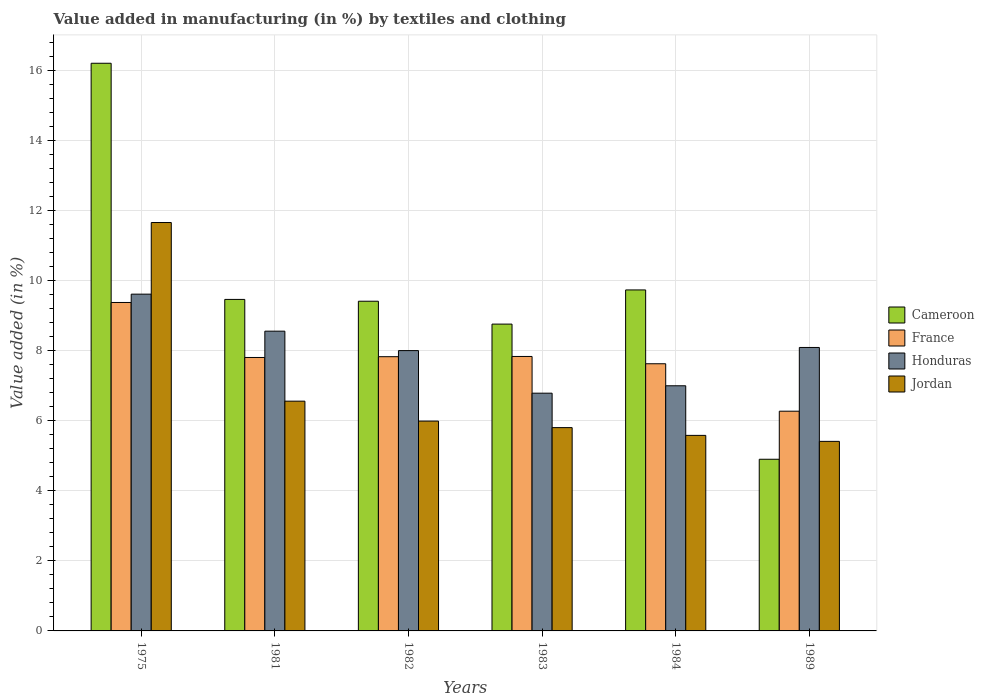How many different coloured bars are there?
Provide a short and direct response. 4. Are the number of bars on each tick of the X-axis equal?
Give a very brief answer. Yes. How many bars are there on the 6th tick from the left?
Your response must be concise. 4. What is the percentage of value added in manufacturing by textiles and clothing in France in 1984?
Your answer should be very brief. 7.63. Across all years, what is the maximum percentage of value added in manufacturing by textiles and clothing in France?
Provide a succinct answer. 9.38. Across all years, what is the minimum percentage of value added in manufacturing by textiles and clothing in Jordan?
Your answer should be compact. 5.41. In which year was the percentage of value added in manufacturing by textiles and clothing in Cameroon maximum?
Give a very brief answer. 1975. What is the total percentage of value added in manufacturing by textiles and clothing in France in the graph?
Provide a short and direct response. 46.77. What is the difference between the percentage of value added in manufacturing by textiles and clothing in Honduras in 1975 and that in 1983?
Keep it short and to the point. 2.83. What is the difference between the percentage of value added in manufacturing by textiles and clothing in Cameroon in 1975 and the percentage of value added in manufacturing by textiles and clothing in France in 1989?
Ensure brevity in your answer.  9.94. What is the average percentage of value added in manufacturing by textiles and clothing in Cameroon per year?
Your response must be concise. 9.75. In the year 1989, what is the difference between the percentage of value added in manufacturing by textiles and clothing in Cameroon and percentage of value added in manufacturing by textiles and clothing in Jordan?
Your response must be concise. -0.51. In how many years, is the percentage of value added in manufacturing by textiles and clothing in Jordan greater than 6.4 %?
Your response must be concise. 2. What is the ratio of the percentage of value added in manufacturing by textiles and clothing in Honduras in 1981 to that in 1989?
Give a very brief answer. 1.06. Is the percentage of value added in manufacturing by textiles and clothing in Honduras in 1981 less than that in 1983?
Your answer should be very brief. No. What is the difference between the highest and the second highest percentage of value added in manufacturing by textiles and clothing in Cameroon?
Make the answer very short. 6.47. What is the difference between the highest and the lowest percentage of value added in manufacturing by textiles and clothing in Jordan?
Offer a terse response. 6.25. In how many years, is the percentage of value added in manufacturing by textiles and clothing in Jordan greater than the average percentage of value added in manufacturing by textiles and clothing in Jordan taken over all years?
Offer a very short reply. 1. What does the 4th bar from the left in 1989 represents?
Your answer should be very brief. Jordan. What does the 4th bar from the right in 1982 represents?
Your answer should be very brief. Cameroon. Is it the case that in every year, the sum of the percentage of value added in manufacturing by textiles and clothing in Jordan and percentage of value added in manufacturing by textiles and clothing in Honduras is greater than the percentage of value added in manufacturing by textiles and clothing in France?
Offer a very short reply. Yes. How many years are there in the graph?
Provide a short and direct response. 6. Are the values on the major ticks of Y-axis written in scientific E-notation?
Your response must be concise. No. Does the graph contain grids?
Your response must be concise. Yes. How are the legend labels stacked?
Provide a short and direct response. Vertical. What is the title of the graph?
Offer a very short reply. Value added in manufacturing (in %) by textiles and clothing. What is the label or title of the X-axis?
Your response must be concise. Years. What is the label or title of the Y-axis?
Provide a succinct answer. Value added (in %). What is the Value added (in %) in Cameroon in 1975?
Your response must be concise. 16.21. What is the Value added (in %) of France in 1975?
Your answer should be compact. 9.38. What is the Value added (in %) of Honduras in 1975?
Keep it short and to the point. 9.62. What is the Value added (in %) of Jordan in 1975?
Make the answer very short. 11.66. What is the Value added (in %) in Cameroon in 1981?
Provide a short and direct response. 9.47. What is the Value added (in %) of France in 1981?
Keep it short and to the point. 7.81. What is the Value added (in %) in Honduras in 1981?
Offer a very short reply. 8.56. What is the Value added (in %) of Jordan in 1981?
Provide a short and direct response. 6.56. What is the Value added (in %) in Cameroon in 1982?
Make the answer very short. 9.42. What is the Value added (in %) in France in 1982?
Offer a terse response. 7.83. What is the Value added (in %) in Honduras in 1982?
Your answer should be very brief. 8.01. What is the Value added (in %) of Jordan in 1982?
Your answer should be compact. 5.99. What is the Value added (in %) of Cameroon in 1983?
Keep it short and to the point. 8.76. What is the Value added (in %) in France in 1983?
Make the answer very short. 7.84. What is the Value added (in %) in Honduras in 1983?
Give a very brief answer. 6.79. What is the Value added (in %) in Jordan in 1983?
Provide a succinct answer. 5.81. What is the Value added (in %) in Cameroon in 1984?
Ensure brevity in your answer.  9.74. What is the Value added (in %) of France in 1984?
Provide a succinct answer. 7.63. What is the Value added (in %) of Honduras in 1984?
Offer a terse response. 7. What is the Value added (in %) of Jordan in 1984?
Ensure brevity in your answer.  5.58. What is the Value added (in %) in Cameroon in 1989?
Provide a succinct answer. 4.9. What is the Value added (in %) in France in 1989?
Keep it short and to the point. 6.28. What is the Value added (in %) of Honduras in 1989?
Keep it short and to the point. 8.1. What is the Value added (in %) in Jordan in 1989?
Provide a succinct answer. 5.41. Across all years, what is the maximum Value added (in %) of Cameroon?
Your answer should be very brief. 16.21. Across all years, what is the maximum Value added (in %) of France?
Provide a short and direct response. 9.38. Across all years, what is the maximum Value added (in %) of Honduras?
Provide a short and direct response. 9.62. Across all years, what is the maximum Value added (in %) of Jordan?
Give a very brief answer. 11.66. Across all years, what is the minimum Value added (in %) in Cameroon?
Provide a succinct answer. 4.9. Across all years, what is the minimum Value added (in %) in France?
Provide a short and direct response. 6.28. Across all years, what is the minimum Value added (in %) in Honduras?
Offer a very short reply. 6.79. Across all years, what is the minimum Value added (in %) of Jordan?
Your response must be concise. 5.41. What is the total Value added (in %) in Cameroon in the graph?
Your answer should be very brief. 58.5. What is the total Value added (in %) of France in the graph?
Keep it short and to the point. 46.77. What is the total Value added (in %) in Honduras in the graph?
Make the answer very short. 48.07. What is the total Value added (in %) in Jordan in the graph?
Provide a succinct answer. 41.02. What is the difference between the Value added (in %) in Cameroon in 1975 and that in 1981?
Provide a short and direct response. 6.74. What is the difference between the Value added (in %) in France in 1975 and that in 1981?
Ensure brevity in your answer.  1.57. What is the difference between the Value added (in %) in Honduras in 1975 and that in 1981?
Your answer should be very brief. 1.06. What is the difference between the Value added (in %) in Jordan in 1975 and that in 1981?
Offer a terse response. 5.1. What is the difference between the Value added (in %) in Cameroon in 1975 and that in 1982?
Provide a succinct answer. 6.8. What is the difference between the Value added (in %) in France in 1975 and that in 1982?
Ensure brevity in your answer.  1.55. What is the difference between the Value added (in %) in Honduras in 1975 and that in 1982?
Offer a terse response. 1.61. What is the difference between the Value added (in %) in Jordan in 1975 and that in 1982?
Offer a terse response. 5.67. What is the difference between the Value added (in %) of Cameroon in 1975 and that in 1983?
Ensure brevity in your answer.  7.45. What is the difference between the Value added (in %) in France in 1975 and that in 1983?
Your answer should be very brief. 1.54. What is the difference between the Value added (in %) in Honduras in 1975 and that in 1983?
Offer a very short reply. 2.83. What is the difference between the Value added (in %) in Jordan in 1975 and that in 1983?
Offer a terse response. 5.86. What is the difference between the Value added (in %) in Cameroon in 1975 and that in 1984?
Provide a short and direct response. 6.47. What is the difference between the Value added (in %) in France in 1975 and that in 1984?
Make the answer very short. 1.75. What is the difference between the Value added (in %) in Honduras in 1975 and that in 1984?
Keep it short and to the point. 2.62. What is the difference between the Value added (in %) of Jordan in 1975 and that in 1984?
Keep it short and to the point. 6.08. What is the difference between the Value added (in %) of Cameroon in 1975 and that in 1989?
Your answer should be very brief. 11.31. What is the difference between the Value added (in %) of France in 1975 and that in 1989?
Ensure brevity in your answer.  3.11. What is the difference between the Value added (in %) of Honduras in 1975 and that in 1989?
Your answer should be very brief. 1.52. What is the difference between the Value added (in %) in Jordan in 1975 and that in 1989?
Your response must be concise. 6.25. What is the difference between the Value added (in %) in Cameroon in 1981 and that in 1982?
Your response must be concise. 0.05. What is the difference between the Value added (in %) in France in 1981 and that in 1982?
Give a very brief answer. -0.02. What is the difference between the Value added (in %) in Honduras in 1981 and that in 1982?
Offer a very short reply. 0.56. What is the difference between the Value added (in %) of Jordan in 1981 and that in 1982?
Provide a succinct answer. 0.57. What is the difference between the Value added (in %) of Cameroon in 1981 and that in 1983?
Your response must be concise. 0.71. What is the difference between the Value added (in %) in France in 1981 and that in 1983?
Provide a short and direct response. -0.03. What is the difference between the Value added (in %) in Honduras in 1981 and that in 1983?
Give a very brief answer. 1.77. What is the difference between the Value added (in %) in Jordan in 1981 and that in 1983?
Offer a terse response. 0.76. What is the difference between the Value added (in %) in Cameroon in 1981 and that in 1984?
Make the answer very short. -0.27. What is the difference between the Value added (in %) in France in 1981 and that in 1984?
Keep it short and to the point. 0.18. What is the difference between the Value added (in %) of Honduras in 1981 and that in 1984?
Ensure brevity in your answer.  1.56. What is the difference between the Value added (in %) in Jordan in 1981 and that in 1984?
Your answer should be very brief. 0.98. What is the difference between the Value added (in %) in Cameroon in 1981 and that in 1989?
Provide a short and direct response. 4.57. What is the difference between the Value added (in %) of France in 1981 and that in 1989?
Your response must be concise. 1.53. What is the difference between the Value added (in %) in Honduras in 1981 and that in 1989?
Provide a short and direct response. 0.47. What is the difference between the Value added (in %) of Jordan in 1981 and that in 1989?
Offer a terse response. 1.15. What is the difference between the Value added (in %) of Cameroon in 1982 and that in 1983?
Your response must be concise. 0.65. What is the difference between the Value added (in %) of France in 1982 and that in 1983?
Your answer should be very brief. -0.01. What is the difference between the Value added (in %) of Honduras in 1982 and that in 1983?
Keep it short and to the point. 1.22. What is the difference between the Value added (in %) of Jordan in 1982 and that in 1983?
Offer a very short reply. 0.19. What is the difference between the Value added (in %) of Cameroon in 1982 and that in 1984?
Ensure brevity in your answer.  -0.32. What is the difference between the Value added (in %) of France in 1982 and that in 1984?
Keep it short and to the point. 0.2. What is the difference between the Value added (in %) in Honduras in 1982 and that in 1984?
Offer a very short reply. 1. What is the difference between the Value added (in %) of Jordan in 1982 and that in 1984?
Offer a terse response. 0.41. What is the difference between the Value added (in %) of Cameroon in 1982 and that in 1989?
Provide a succinct answer. 4.51. What is the difference between the Value added (in %) in France in 1982 and that in 1989?
Offer a very short reply. 1.56. What is the difference between the Value added (in %) of Honduras in 1982 and that in 1989?
Offer a very short reply. -0.09. What is the difference between the Value added (in %) of Jordan in 1982 and that in 1989?
Provide a short and direct response. 0.58. What is the difference between the Value added (in %) of Cameroon in 1983 and that in 1984?
Your response must be concise. -0.98. What is the difference between the Value added (in %) in France in 1983 and that in 1984?
Provide a succinct answer. 0.21. What is the difference between the Value added (in %) in Honduras in 1983 and that in 1984?
Keep it short and to the point. -0.21. What is the difference between the Value added (in %) of Jordan in 1983 and that in 1984?
Keep it short and to the point. 0.22. What is the difference between the Value added (in %) in Cameroon in 1983 and that in 1989?
Make the answer very short. 3.86. What is the difference between the Value added (in %) in France in 1983 and that in 1989?
Offer a terse response. 1.56. What is the difference between the Value added (in %) of Honduras in 1983 and that in 1989?
Provide a short and direct response. -1.31. What is the difference between the Value added (in %) of Jordan in 1983 and that in 1989?
Give a very brief answer. 0.39. What is the difference between the Value added (in %) of Cameroon in 1984 and that in 1989?
Provide a succinct answer. 4.84. What is the difference between the Value added (in %) of France in 1984 and that in 1989?
Ensure brevity in your answer.  1.35. What is the difference between the Value added (in %) of Honduras in 1984 and that in 1989?
Provide a succinct answer. -1.09. What is the difference between the Value added (in %) in Jordan in 1984 and that in 1989?
Your response must be concise. 0.17. What is the difference between the Value added (in %) of Cameroon in 1975 and the Value added (in %) of France in 1981?
Provide a succinct answer. 8.4. What is the difference between the Value added (in %) in Cameroon in 1975 and the Value added (in %) in Honduras in 1981?
Make the answer very short. 7.65. What is the difference between the Value added (in %) of Cameroon in 1975 and the Value added (in %) of Jordan in 1981?
Your response must be concise. 9.65. What is the difference between the Value added (in %) of France in 1975 and the Value added (in %) of Honduras in 1981?
Your answer should be very brief. 0.82. What is the difference between the Value added (in %) of France in 1975 and the Value added (in %) of Jordan in 1981?
Give a very brief answer. 2.82. What is the difference between the Value added (in %) in Honduras in 1975 and the Value added (in %) in Jordan in 1981?
Your response must be concise. 3.06. What is the difference between the Value added (in %) in Cameroon in 1975 and the Value added (in %) in France in 1982?
Keep it short and to the point. 8.38. What is the difference between the Value added (in %) in Cameroon in 1975 and the Value added (in %) in Honduras in 1982?
Your answer should be very brief. 8.21. What is the difference between the Value added (in %) in Cameroon in 1975 and the Value added (in %) in Jordan in 1982?
Your answer should be compact. 10.22. What is the difference between the Value added (in %) of France in 1975 and the Value added (in %) of Honduras in 1982?
Offer a very short reply. 1.37. What is the difference between the Value added (in %) of France in 1975 and the Value added (in %) of Jordan in 1982?
Offer a terse response. 3.39. What is the difference between the Value added (in %) of Honduras in 1975 and the Value added (in %) of Jordan in 1982?
Offer a terse response. 3.63. What is the difference between the Value added (in %) of Cameroon in 1975 and the Value added (in %) of France in 1983?
Give a very brief answer. 8.37. What is the difference between the Value added (in %) of Cameroon in 1975 and the Value added (in %) of Honduras in 1983?
Your answer should be compact. 9.42. What is the difference between the Value added (in %) in Cameroon in 1975 and the Value added (in %) in Jordan in 1983?
Provide a succinct answer. 10.41. What is the difference between the Value added (in %) in France in 1975 and the Value added (in %) in Honduras in 1983?
Keep it short and to the point. 2.59. What is the difference between the Value added (in %) of France in 1975 and the Value added (in %) of Jordan in 1983?
Provide a short and direct response. 3.57. What is the difference between the Value added (in %) in Honduras in 1975 and the Value added (in %) in Jordan in 1983?
Keep it short and to the point. 3.81. What is the difference between the Value added (in %) of Cameroon in 1975 and the Value added (in %) of France in 1984?
Give a very brief answer. 8.58. What is the difference between the Value added (in %) in Cameroon in 1975 and the Value added (in %) in Honduras in 1984?
Offer a terse response. 9.21. What is the difference between the Value added (in %) of Cameroon in 1975 and the Value added (in %) of Jordan in 1984?
Provide a succinct answer. 10.63. What is the difference between the Value added (in %) of France in 1975 and the Value added (in %) of Honduras in 1984?
Give a very brief answer. 2.38. What is the difference between the Value added (in %) in France in 1975 and the Value added (in %) in Jordan in 1984?
Offer a very short reply. 3.8. What is the difference between the Value added (in %) in Honduras in 1975 and the Value added (in %) in Jordan in 1984?
Provide a short and direct response. 4.03. What is the difference between the Value added (in %) of Cameroon in 1975 and the Value added (in %) of France in 1989?
Give a very brief answer. 9.94. What is the difference between the Value added (in %) in Cameroon in 1975 and the Value added (in %) in Honduras in 1989?
Ensure brevity in your answer.  8.12. What is the difference between the Value added (in %) in Cameroon in 1975 and the Value added (in %) in Jordan in 1989?
Keep it short and to the point. 10.8. What is the difference between the Value added (in %) of France in 1975 and the Value added (in %) of Honduras in 1989?
Make the answer very short. 1.28. What is the difference between the Value added (in %) of France in 1975 and the Value added (in %) of Jordan in 1989?
Make the answer very short. 3.97. What is the difference between the Value added (in %) of Honduras in 1975 and the Value added (in %) of Jordan in 1989?
Make the answer very short. 4.21. What is the difference between the Value added (in %) in Cameroon in 1981 and the Value added (in %) in France in 1982?
Give a very brief answer. 1.64. What is the difference between the Value added (in %) of Cameroon in 1981 and the Value added (in %) of Honduras in 1982?
Make the answer very short. 1.46. What is the difference between the Value added (in %) in Cameroon in 1981 and the Value added (in %) in Jordan in 1982?
Make the answer very short. 3.47. What is the difference between the Value added (in %) in France in 1981 and the Value added (in %) in Honduras in 1982?
Give a very brief answer. -0.2. What is the difference between the Value added (in %) in France in 1981 and the Value added (in %) in Jordan in 1982?
Give a very brief answer. 1.82. What is the difference between the Value added (in %) of Honduras in 1981 and the Value added (in %) of Jordan in 1982?
Make the answer very short. 2.57. What is the difference between the Value added (in %) in Cameroon in 1981 and the Value added (in %) in France in 1983?
Your response must be concise. 1.63. What is the difference between the Value added (in %) of Cameroon in 1981 and the Value added (in %) of Honduras in 1983?
Your answer should be very brief. 2.68. What is the difference between the Value added (in %) in Cameroon in 1981 and the Value added (in %) in Jordan in 1983?
Provide a succinct answer. 3.66. What is the difference between the Value added (in %) of France in 1981 and the Value added (in %) of Honduras in 1983?
Your response must be concise. 1.02. What is the difference between the Value added (in %) in France in 1981 and the Value added (in %) in Jordan in 1983?
Keep it short and to the point. 2. What is the difference between the Value added (in %) of Honduras in 1981 and the Value added (in %) of Jordan in 1983?
Your answer should be very brief. 2.75. What is the difference between the Value added (in %) in Cameroon in 1981 and the Value added (in %) in France in 1984?
Ensure brevity in your answer.  1.84. What is the difference between the Value added (in %) of Cameroon in 1981 and the Value added (in %) of Honduras in 1984?
Provide a short and direct response. 2.47. What is the difference between the Value added (in %) in Cameroon in 1981 and the Value added (in %) in Jordan in 1984?
Provide a short and direct response. 3.88. What is the difference between the Value added (in %) in France in 1981 and the Value added (in %) in Honduras in 1984?
Ensure brevity in your answer.  0.81. What is the difference between the Value added (in %) in France in 1981 and the Value added (in %) in Jordan in 1984?
Keep it short and to the point. 2.23. What is the difference between the Value added (in %) of Honduras in 1981 and the Value added (in %) of Jordan in 1984?
Your response must be concise. 2.98. What is the difference between the Value added (in %) in Cameroon in 1981 and the Value added (in %) in France in 1989?
Ensure brevity in your answer.  3.19. What is the difference between the Value added (in %) of Cameroon in 1981 and the Value added (in %) of Honduras in 1989?
Your answer should be very brief. 1.37. What is the difference between the Value added (in %) of Cameroon in 1981 and the Value added (in %) of Jordan in 1989?
Give a very brief answer. 4.05. What is the difference between the Value added (in %) of France in 1981 and the Value added (in %) of Honduras in 1989?
Provide a succinct answer. -0.29. What is the difference between the Value added (in %) of France in 1981 and the Value added (in %) of Jordan in 1989?
Make the answer very short. 2.4. What is the difference between the Value added (in %) in Honduras in 1981 and the Value added (in %) in Jordan in 1989?
Provide a succinct answer. 3.15. What is the difference between the Value added (in %) of Cameroon in 1982 and the Value added (in %) of France in 1983?
Offer a terse response. 1.58. What is the difference between the Value added (in %) in Cameroon in 1982 and the Value added (in %) in Honduras in 1983?
Offer a very short reply. 2.63. What is the difference between the Value added (in %) in Cameroon in 1982 and the Value added (in %) in Jordan in 1983?
Your answer should be compact. 3.61. What is the difference between the Value added (in %) in France in 1982 and the Value added (in %) in Honduras in 1983?
Your answer should be compact. 1.04. What is the difference between the Value added (in %) in France in 1982 and the Value added (in %) in Jordan in 1983?
Offer a very short reply. 2.03. What is the difference between the Value added (in %) in Honduras in 1982 and the Value added (in %) in Jordan in 1983?
Ensure brevity in your answer.  2.2. What is the difference between the Value added (in %) of Cameroon in 1982 and the Value added (in %) of France in 1984?
Provide a short and direct response. 1.79. What is the difference between the Value added (in %) in Cameroon in 1982 and the Value added (in %) in Honduras in 1984?
Give a very brief answer. 2.41. What is the difference between the Value added (in %) of Cameroon in 1982 and the Value added (in %) of Jordan in 1984?
Keep it short and to the point. 3.83. What is the difference between the Value added (in %) in France in 1982 and the Value added (in %) in Honduras in 1984?
Provide a short and direct response. 0.83. What is the difference between the Value added (in %) in France in 1982 and the Value added (in %) in Jordan in 1984?
Offer a terse response. 2.25. What is the difference between the Value added (in %) of Honduras in 1982 and the Value added (in %) of Jordan in 1984?
Your response must be concise. 2.42. What is the difference between the Value added (in %) of Cameroon in 1982 and the Value added (in %) of France in 1989?
Make the answer very short. 3.14. What is the difference between the Value added (in %) in Cameroon in 1982 and the Value added (in %) in Honduras in 1989?
Provide a succinct answer. 1.32. What is the difference between the Value added (in %) in Cameroon in 1982 and the Value added (in %) in Jordan in 1989?
Make the answer very short. 4. What is the difference between the Value added (in %) in France in 1982 and the Value added (in %) in Honduras in 1989?
Make the answer very short. -0.26. What is the difference between the Value added (in %) of France in 1982 and the Value added (in %) of Jordan in 1989?
Provide a succinct answer. 2.42. What is the difference between the Value added (in %) in Honduras in 1982 and the Value added (in %) in Jordan in 1989?
Your response must be concise. 2.59. What is the difference between the Value added (in %) in Cameroon in 1983 and the Value added (in %) in France in 1984?
Provide a succinct answer. 1.13. What is the difference between the Value added (in %) of Cameroon in 1983 and the Value added (in %) of Honduras in 1984?
Make the answer very short. 1.76. What is the difference between the Value added (in %) in Cameroon in 1983 and the Value added (in %) in Jordan in 1984?
Your answer should be very brief. 3.18. What is the difference between the Value added (in %) of France in 1983 and the Value added (in %) of Honduras in 1984?
Provide a succinct answer. 0.84. What is the difference between the Value added (in %) of France in 1983 and the Value added (in %) of Jordan in 1984?
Provide a succinct answer. 2.25. What is the difference between the Value added (in %) of Honduras in 1983 and the Value added (in %) of Jordan in 1984?
Ensure brevity in your answer.  1.21. What is the difference between the Value added (in %) in Cameroon in 1983 and the Value added (in %) in France in 1989?
Your response must be concise. 2.49. What is the difference between the Value added (in %) of Cameroon in 1983 and the Value added (in %) of Honduras in 1989?
Your response must be concise. 0.67. What is the difference between the Value added (in %) of Cameroon in 1983 and the Value added (in %) of Jordan in 1989?
Your answer should be very brief. 3.35. What is the difference between the Value added (in %) in France in 1983 and the Value added (in %) in Honduras in 1989?
Provide a succinct answer. -0.26. What is the difference between the Value added (in %) in France in 1983 and the Value added (in %) in Jordan in 1989?
Offer a terse response. 2.42. What is the difference between the Value added (in %) of Honduras in 1983 and the Value added (in %) of Jordan in 1989?
Offer a very short reply. 1.38. What is the difference between the Value added (in %) in Cameroon in 1984 and the Value added (in %) in France in 1989?
Your answer should be compact. 3.46. What is the difference between the Value added (in %) in Cameroon in 1984 and the Value added (in %) in Honduras in 1989?
Your answer should be very brief. 1.64. What is the difference between the Value added (in %) of Cameroon in 1984 and the Value added (in %) of Jordan in 1989?
Ensure brevity in your answer.  4.33. What is the difference between the Value added (in %) of France in 1984 and the Value added (in %) of Honduras in 1989?
Your answer should be compact. -0.47. What is the difference between the Value added (in %) in France in 1984 and the Value added (in %) in Jordan in 1989?
Provide a succinct answer. 2.22. What is the difference between the Value added (in %) of Honduras in 1984 and the Value added (in %) of Jordan in 1989?
Keep it short and to the point. 1.59. What is the average Value added (in %) in Cameroon per year?
Make the answer very short. 9.75. What is the average Value added (in %) in France per year?
Provide a short and direct response. 7.79. What is the average Value added (in %) of Honduras per year?
Offer a very short reply. 8.01. What is the average Value added (in %) in Jordan per year?
Make the answer very short. 6.84. In the year 1975, what is the difference between the Value added (in %) of Cameroon and Value added (in %) of France?
Keep it short and to the point. 6.83. In the year 1975, what is the difference between the Value added (in %) of Cameroon and Value added (in %) of Honduras?
Keep it short and to the point. 6.59. In the year 1975, what is the difference between the Value added (in %) of Cameroon and Value added (in %) of Jordan?
Offer a very short reply. 4.55. In the year 1975, what is the difference between the Value added (in %) in France and Value added (in %) in Honduras?
Keep it short and to the point. -0.24. In the year 1975, what is the difference between the Value added (in %) of France and Value added (in %) of Jordan?
Your response must be concise. -2.28. In the year 1975, what is the difference between the Value added (in %) of Honduras and Value added (in %) of Jordan?
Keep it short and to the point. -2.05. In the year 1981, what is the difference between the Value added (in %) in Cameroon and Value added (in %) in France?
Offer a very short reply. 1.66. In the year 1981, what is the difference between the Value added (in %) in Cameroon and Value added (in %) in Honduras?
Make the answer very short. 0.91. In the year 1981, what is the difference between the Value added (in %) in Cameroon and Value added (in %) in Jordan?
Ensure brevity in your answer.  2.91. In the year 1981, what is the difference between the Value added (in %) in France and Value added (in %) in Honduras?
Ensure brevity in your answer.  -0.75. In the year 1981, what is the difference between the Value added (in %) in France and Value added (in %) in Jordan?
Your answer should be compact. 1.25. In the year 1981, what is the difference between the Value added (in %) of Honduras and Value added (in %) of Jordan?
Offer a very short reply. 2. In the year 1982, what is the difference between the Value added (in %) in Cameroon and Value added (in %) in France?
Your answer should be compact. 1.58. In the year 1982, what is the difference between the Value added (in %) in Cameroon and Value added (in %) in Honduras?
Your answer should be very brief. 1.41. In the year 1982, what is the difference between the Value added (in %) in Cameroon and Value added (in %) in Jordan?
Give a very brief answer. 3.42. In the year 1982, what is the difference between the Value added (in %) in France and Value added (in %) in Honduras?
Your answer should be very brief. -0.17. In the year 1982, what is the difference between the Value added (in %) of France and Value added (in %) of Jordan?
Offer a terse response. 1.84. In the year 1982, what is the difference between the Value added (in %) of Honduras and Value added (in %) of Jordan?
Give a very brief answer. 2.01. In the year 1983, what is the difference between the Value added (in %) of Cameroon and Value added (in %) of France?
Keep it short and to the point. 0.92. In the year 1983, what is the difference between the Value added (in %) in Cameroon and Value added (in %) in Honduras?
Offer a terse response. 1.97. In the year 1983, what is the difference between the Value added (in %) of Cameroon and Value added (in %) of Jordan?
Make the answer very short. 2.96. In the year 1983, what is the difference between the Value added (in %) of France and Value added (in %) of Honduras?
Provide a short and direct response. 1.05. In the year 1983, what is the difference between the Value added (in %) in France and Value added (in %) in Jordan?
Offer a very short reply. 2.03. In the year 1983, what is the difference between the Value added (in %) of Honduras and Value added (in %) of Jordan?
Make the answer very short. 0.98. In the year 1984, what is the difference between the Value added (in %) in Cameroon and Value added (in %) in France?
Keep it short and to the point. 2.11. In the year 1984, what is the difference between the Value added (in %) in Cameroon and Value added (in %) in Honduras?
Your response must be concise. 2.74. In the year 1984, what is the difference between the Value added (in %) of Cameroon and Value added (in %) of Jordan?
Your response must be concise. 4.15. In the year 1984, what is the difference between the Value added (in %) of France and Value added (in %) of Honduras?
Give a very brief answer. 0.63. In the year 1984, what is the difference between the Value added (in %) in France and Value added (in %) in Jordan?
Offer a terse response. 2.05. In the year 1984, what is the difference between the Value added (in %) of Honduras and Value added (in %) of Jordan?
Your answer should be compact. 1.42. In the year 1989, what is the difference between the Value added (in %) of Cameroon and Value added (in %) of France?
Ensure brevity in your answer.  -1.37. In the year 1989, what is the difference between the Value added (in %) of Cameroon and Value added (in %) of Honduras?
Your response must be concise. -3.19. In the year 1989, what is the difference between the Value added (in %) in Cameroon and Value added (in %) in Jordan?
Your response must be concise. -0.51. In the year 1989, what is the difference between the Value added (in %) of France and Value added (in %) of Honduras?
Give a very brief answer. -1.82. In the year 1989, what is the difference between the Value added (in %) in France and Value added (in %) in Jordan?
Offer a terse response. 0.86. In the year 1989, what is the difference between the Value added (in %) of Honduras and Value added (in %) of Jordan?
Your answer should be very brief. 2.68. What is the ratio of the Value added (in %) in Cameroon in 1975 to that in 1981?
Ensure brevity in your answer.  1.71. What is the ratio of the Value added (in %) in France in 1975 to that in 1981?
Provide a succinct answer. 1.2. What is the ratio of the Value added (in %) in Honduras in 1975 to that in 1981?
Make the answer very short. 1.12. What is the ratio of the Value added (in %) in Jordan in 1975 to that in 1981?
Keep it short and to the point. 1.78. What is the ratio of the Value added (in %) in Cameroon in 1975 to that in 1982?
Your answer should be very brief. 1.72. What is the ratio of the Value added (in %) of France in 1975 to that in 1982?
Your answer should be very brief. 1.2. What is the ratio of the Value added (in %) in Honduras in 1975 to that in 1982?
Provide a short and direct response. 1.2. What is the ratio of the Value added (in %) in Jordan in 1975 to that in 1982?
Ensure brevity in your answer.  1.95. What is the ratio of the Value added (in %) in Cameroon in 1975 to that in 1983?
Offer a terse response. 1.85. What is the ratio of the Value added (in %) in France in 1975 to that in 1983?
Your answer should be very brief. 1.2. What is the ratio of the Value added (in %) in Honduras in 1975 to that in 1983?
Your answer should be compact. 1.42. What is the ratio of the Value added (in %) in Jordan in 1975 to that in 1983?
Offer a very short reply. 2.01. What is the ratio of the Value added (in %) of Cameroon in 1975 to that in 1984?
Offer a very short reply. 1.66. What is the ratio of the Value added (in %) in France in 1975 to that in 1984?
Make the answer very short. 1.23. What is the ratio of the Value added (in %) in Honduras in 1975 to that in 1984?
Provide a short and direct response. 1.37. What is the ratio of the Value added (in %) in Jordan in 1975 to that in 1984?
Your response must be concise. 2.09. What is the ratio of the Value added (in %) in Cameroon in 1975 to that in 1989?
Ensure brevity in your answer.  3.31. What is the ratio of the Value added (in %) in France in 1975 to that in 1989?
Your answer should be compact. 1.49. What is the ratio of the Value added (in %) of Honduras in 1975 to that in 1989?
Offer a terse response. 1.19. What is the ratio of the Value added (in %) of Jordan in 1975 to that in 1989?
Make the answer very short. 2.15. What is the ratio of the Value added (in %) in Cameroon in 1981 to that in 1982?
Offer a very short reply. 1.01. What is the ratio of the Value added (in %) in France in 1981 to that in 1982?
Make the answer very short. 1. What is the ratio of the Value added (in %) of Honduras in 1981 to that in 1982?
Your response must be concise. 1.07. What is the ratio of the Value added (in %) in Jordan in 1981 to that in 1982?
Ensure brevity in your answer.  1.09. What is the ratio of the Value added (in %) in Cameroon in 1981 to that in 1983?
Provide a succinct answer. 1.08. What is the ratio of the Value added (in %) in France in 1981 to that in 1983?
Offer a very short reply. 1. What is the ratio of the Value added (in %) of Honduras in 1981 to that in 1983?
Ensure brevity in your answer.  1.26. What is the ratio of the Value added (in %) in Jordan in 1981 to that in 1983?
Offer a terse response. 1.13. What is the ratio of the Value added (in %) of Cameroon in 1981 to that in 1984?
Offer a very short reply. 0.97. What is the ratio of the Value added (in %) in France in 1981 to that in 1984?
Provide a succinct answer. 1.02. What is the ratio of the Value added (in %) in Honduras in 1981 to that in 1984?
Ensure brevity in your answer.  1.22. What is the ratio of the Value added (in %) in Jordan in 1981 to that in 1984?
Your response must be concise. 1.18. What is the ratio of the Value added (in %) in Cameroon in 1981 to that in 1989?
Give a very brief answer. 1.93. What is the ratio of the Value added (in %) of France in 1981 to that in 1989?
Keep it short and to the point. 1.24. What is the ratio of the Value added (in %) of Honduras in 1981 to that in 1989?
Ensure brevity in your answer.  1.06. What is the ratio of the Value added (in %) of Jordan in 1981 to that in 1989?
Provide a succinct answer. 1.21. What is the ratio of the Value added (in %) in Cameroon in 1982 to that in 1983?
Give a very brief answer. 1.07. What is the ratio of the Value added (in %) in Honduras in 1982 to that in 1983?
Provide a succinct answer. 1.18. What is the ratio of the Value added (in %) of Jordan in 1982 to that in 1983?
Offer a terse response. 1.03. What is the ratio of the Value added (in %) in Cameroon in 1982 to that in 1984?
Offer a very short reply. 0.97. What is the ratio of the Value added (in %) of France in 1982 to that in 1984?
Offer a very short reply. 1.03. What is the ratio of the Value added (in %) in Honduras in 1982 to that in 1984?
Offer a very short reply. 1.14. What is the ratio of the Value added (in %) in Jordan in 1982 to that in 1984?
Provide a succinct answer. 1.07. What is the ratio of the Value added (in %) of Cameroon in 1982 to that in 1989?
Provide a short and direct response. 1.92. What is the ratio of the Value added (in %) in France in 1982 to that in 1989?
Offer a terse response. 1.25. What is the ratio of the Value added (in %) in Honduras in 1982 to that in 1989?
Offer a very short reply. 0.99. What is the ratio of the Value added (in %) in Jordan in 1982 to that in 1989?
Keep it short and to the point. 1.11. What is the ratio of the Value added (in %) of Cameroon in 1983 to that in 1984?
Provide a short and direct response. 0.9. What is the ratio of the Value added (in %) of France in 1983 to that in 1984?
Your answer should be compact. 1.03. What is the ratio of the Value added (in %) in Honduras in 1983 to that in 1984?
Provide a succinct answer. 0.97. What is the ratio of the Value added (in %) of Jordan in 1983 to that in 1984?
Offer a very short reply. 1.04. What is the ratio of the Value added (in %) of Cameroon in 1983 to that in 1989?
Ensure brevity in your answer.  1.79. What is the ratio of the Value added (in %) of France in 1983 to that in 1989?
Your answer should be very brief. 1.25. What is the ratio of the Value added (in %) in Honduras in 1983 to that in 1989?
Provide a short and direct response. 0.84. What is the ratio of the Value added (in %) in Jordan in 1983 to that in 1989?
Make the answer very short. 1.07. What is the ratio of the Value added (in %) of Cameroon in 1984 to that in 1989?
Give a very brief answer. 1.99. What is the ratio of the Value added (in %) of France in 1984 to that in 1989?
Your answer should be compact. 1.22. What is the ratio of the Value added (in %) in Honduras in 1984 to that in 1989?
Give a very brief answer. 0.86. What is the ratio of the Value added (in %) in Jordan in 1984 to that in 1989?
Your answer should be compact. 1.03. What is the difference between the highest and the second highest Value added (in %) in Cameroon?
Your answer should be compact. 6.47. What is the difference between the highest and the second highest Value added (in %) in France?
Keep it short and to the point. 1.54. What is the difference between the highest and the second highest Value added (in %) in Honduras?
Give a very brief answer. 1.06. What is the difference between the highest and the second highest Value added (in %) of Jordan?
Ensure brevity in your answer.  5.1. What is the difference between the highest and the lowest Value added (in %) in Cameroon?
Provide a short and direct response. 11.31. What is the difference between the highest and the lowest Value added (in %) in France?
Your answer should be compact. 3.11. What is the difference between the highest and the lowest Value added (in %) of Honduras?
Keep it short and to the point. 2.83. What is the difference between the highest and the lowest Value added (in %) of Jordan?
Give a very brief answer. 6.25. 